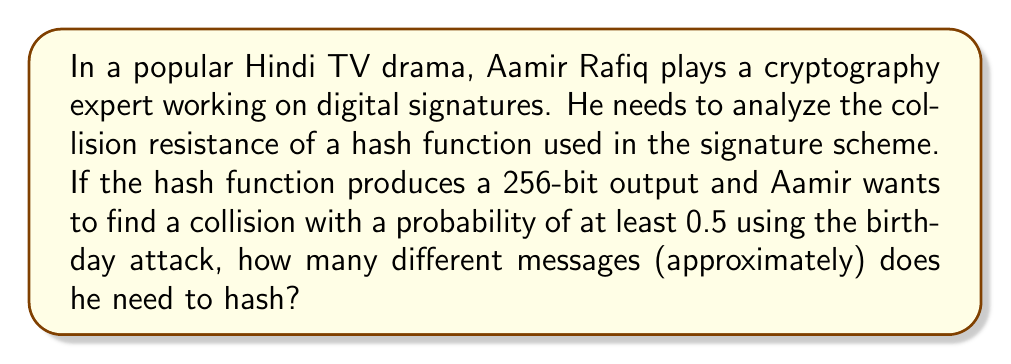Help me with this question. Let's approach this step-by-step:

1) The birthday attack is based on the birthday paradox, which states that in a group of 23 people, there's a 50% chance that two people share the same birthday.

2) For a hash function with an n-bit output, the number of possible hash values is $2^n$.

3) In this case, we have a 256-bit hash function, so $n = 256$.

4) The formula for the number of hashes needed for a 50% chance of collision is approximately:

   $$m \approx \sqrt{2 \ln(2) \cdot 2^n}$$

5) Substituting $n = 256$:

   $$m \approx \sqrt{2 \ln(2) \cdot 2^{256}}$$

6) Simplifying:
   
   $$m \approx \sqrt{2 \ln(2)} \cdot 2^{128}$$

7) $\sqrt{2 \ln(2)} \approx 1.17741$

8) Therefore:

   $$m \approx 1.17741 \cdot 2^{128} \approx 2^{128}$$

9) $2^{128}$ is approximately equal to $3.4 \times 10^{38}$.
Answer: $2^{128}$ or $3.4 \times 10^{38}$ messages 